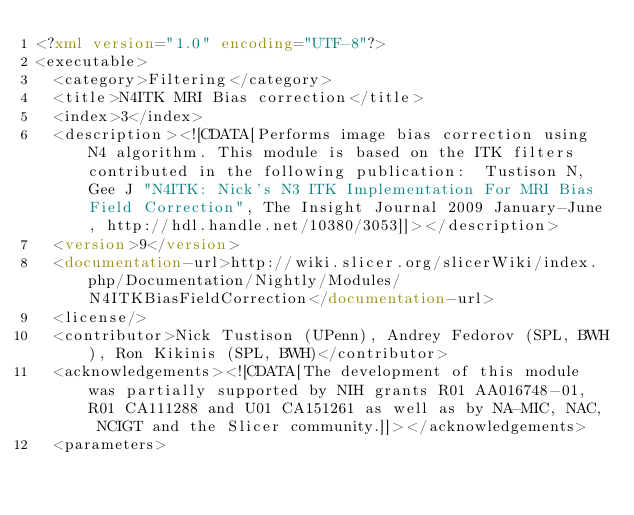Convert code to text. <code><loc_0><loc_0><loc_500><loc_500><_XML_><?xml version="1.0" encoding="UTF-8"?>
<executable>
  <category>Filtering</category>
  <title>N4ITK MRI Bias correction</title>
  <index>3</index>
  <description><![CDATA[Performs image bias correction using N4 algorithm. This module is based on the ITK filters contributed in the following publication:  Tustison N, Gee J "N4ITK: Nick's N3 ITK Implementation For MRI Bias Field Correction", The Insight Journal 2009 January-June, http://hdl.handle.net/10380/3053]]></description>
  <version>9</version>
  <documentation-url>http://wiki.slicer.org/slicerWiki/index.php/Documentation/Nightly/Modules/N4ITKBiasFieldCorrection</documentation-url>
  <license/>
  <contributor>Nick Tustison (UPenn), Andrey Fedorov (SPL, BWH), Ron Kikinis (SPL, BWH)</contributor>
  <acknowledgements><![CDATA[The development of this module was partially supported by NIH grants R01 AA016748-01, R01 CA111288 and U01 CA151261 as well as by NA-MIC, NAC, NCIGT and the Slicer community.]]></acknowledgements>
  <parameters></code> 